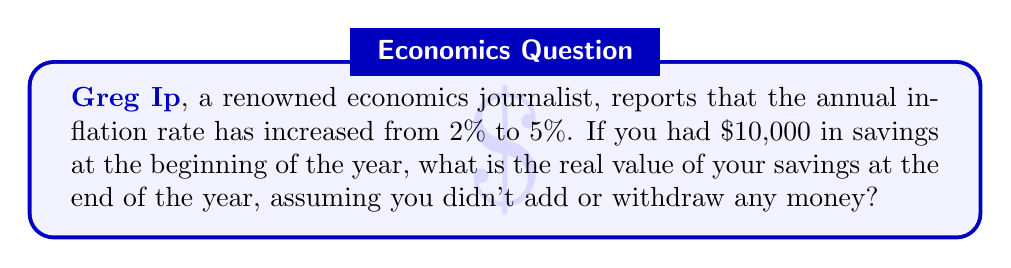Teach me how to tackle this problem. To solve this problem, we need to understand how inflation affects purchasing power. Inflation erodes the value of money over time, reducing its purchasing power. To calculate the real value of savings after inflation, we can use the following formula:

$$\text{Real Value} = \frac{\text{Nominal Value}}{(1 + \text{Inflation Rate})}$$

Let's break down the solution step-by-step:

1. Identify the given information:
   - Initial savings (Nominal Value): $10,000
   - Inflation rate: 5% or 0.05

2. Apply the formula:
   $$\text{Real Value} = \frac{$10,000}{(1 + 0.05)}$$

3. Calculate:
   $$\text{Real Value} = \frac{$10,000}{1.05}$$
   $$\text{Real Value} = $9,523.81$$

4. Round to the nearest cent:
   $$\text{Real Value} ≈ $9,523.81$$

This means that while you nominally still have $10,000 in your savings account, its purchasing power has decreased due to inflation. The $10,000 at the end of the year can only buy goods and services equivalent to what $9,523.81 could buy at the beginning of the year.

To calculate the loss in purchasing power:
$$\text{Loss} = $10,000 - $9,523.81 = $476.19$$

This represents a 4.76% decrease in purchasing power, which aligns with the 5% inflation rate (the slight difference is due to the compounding effect).
Answer: $9,523.81 